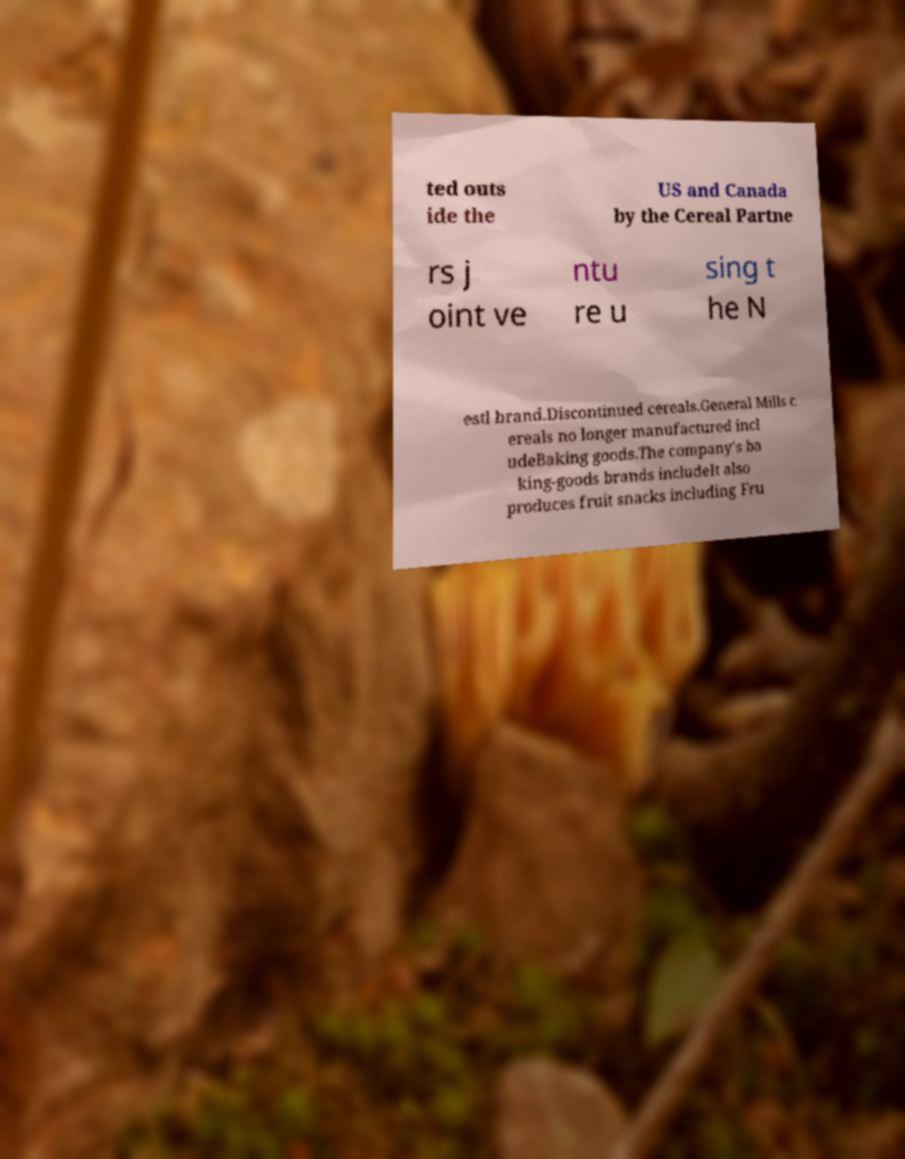Could you extract and type out the text from this image? ted outs ide the US and Canada by the Cereal Partne rs j oint ve ntu re u sing t he N estl brand.Discontinued cereals.General Mills c ereals no longer manufactured incl udeBaking goods.The company's ba king-goods brands includeIt also produces fruit snacks including Fru 